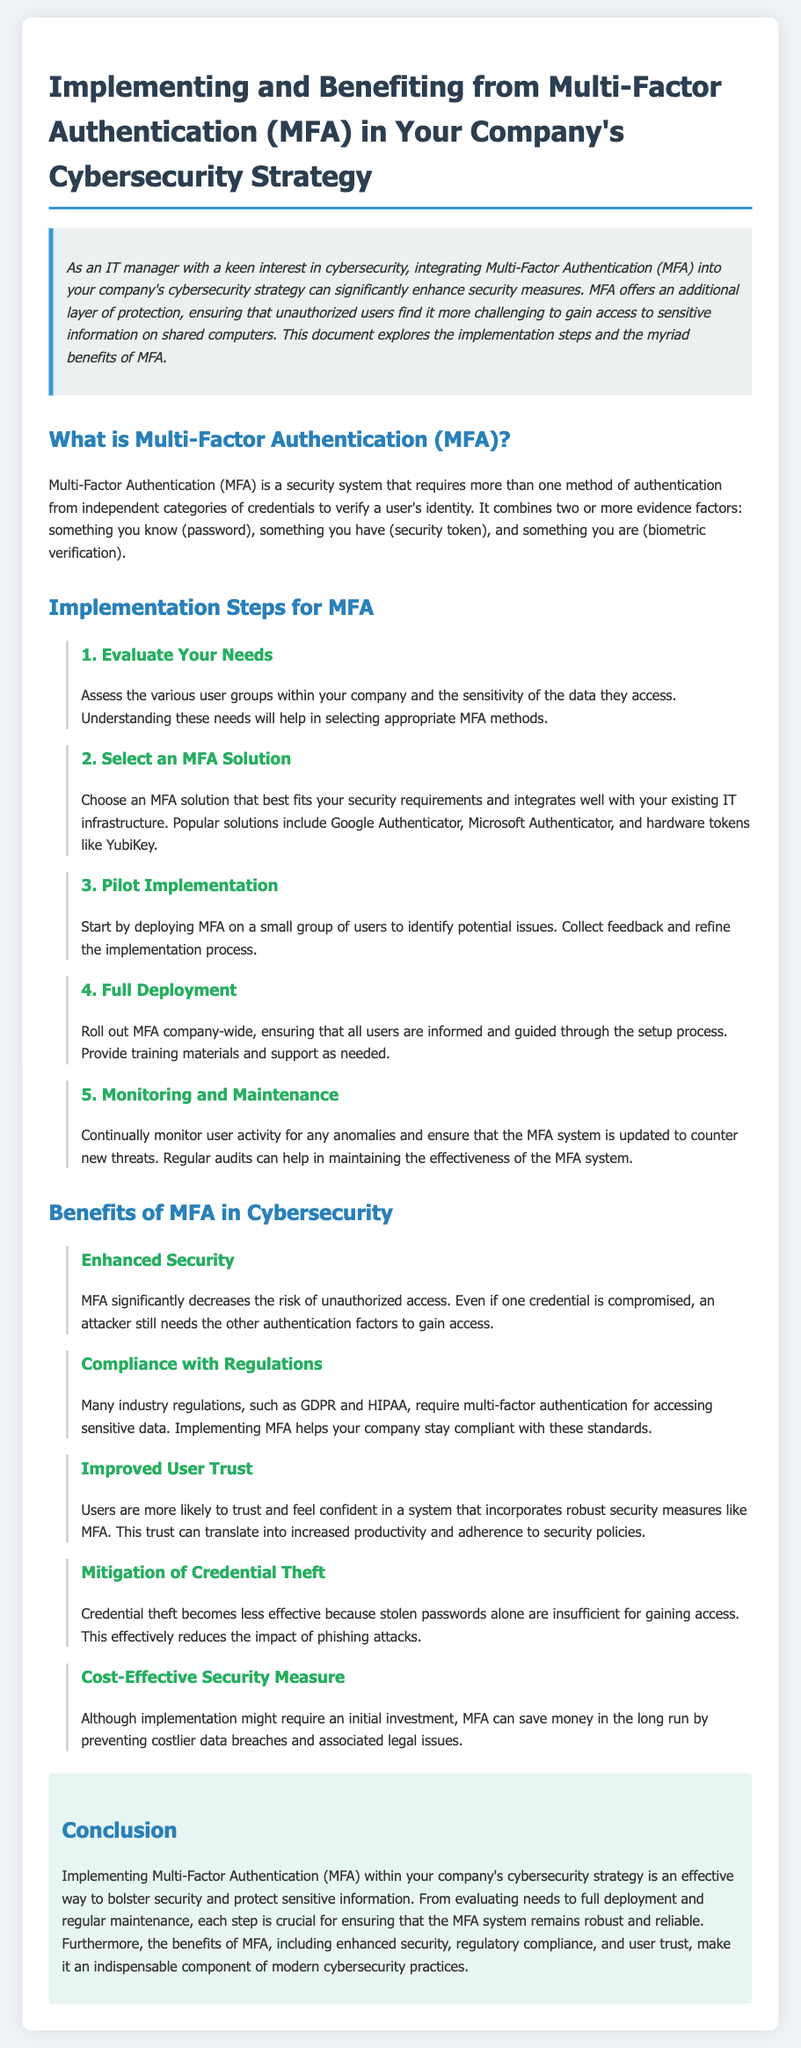What is MFA? MFA is defined as a security system that requires more than one method of authentication from independent categories of credentials to verify a user's identity.
Answer: A security system What is the first step in implementing MFA? The first step involves assessing the various user groups within your company and the sensitivity of the data they access.
Answer: Evaluate Your Needs Which solution did the document mention as an example of MFA? Examples provided in the document include Google Authenticator, Microsoft Authenticator, and hardware tokens like YubiKey.
Answer: Google Authenticator What is one benefit of implementing MFA? One of the benefits of MFA is that it significantly decreases the risk of unauthorized access.
Answer: Enhanced Security How many steps are there in the implementation of MFA? The document outlines five steps for implementing MFA.
Answer: Five steps What is one way MFA helps with regulatory compliance? MFA helps with compliance as many industry regulations, such as GDPR and HIPAA, require multi-factor authentication for accessing sensitive data.
Answer: Compliance with Regulations What is highlighted as a consequence of credential theft being mitigated by MFA? The document states that credential theft becomes less effective because stolen passwords alone are insufficient for gaining access.
Answer: Less effective What is stated about user trust in relation to MFA? The document mentions that users are more likely to trust and feel confident in a system that incorporates robust security measures like MFA.
Answer: Improved User Trust 